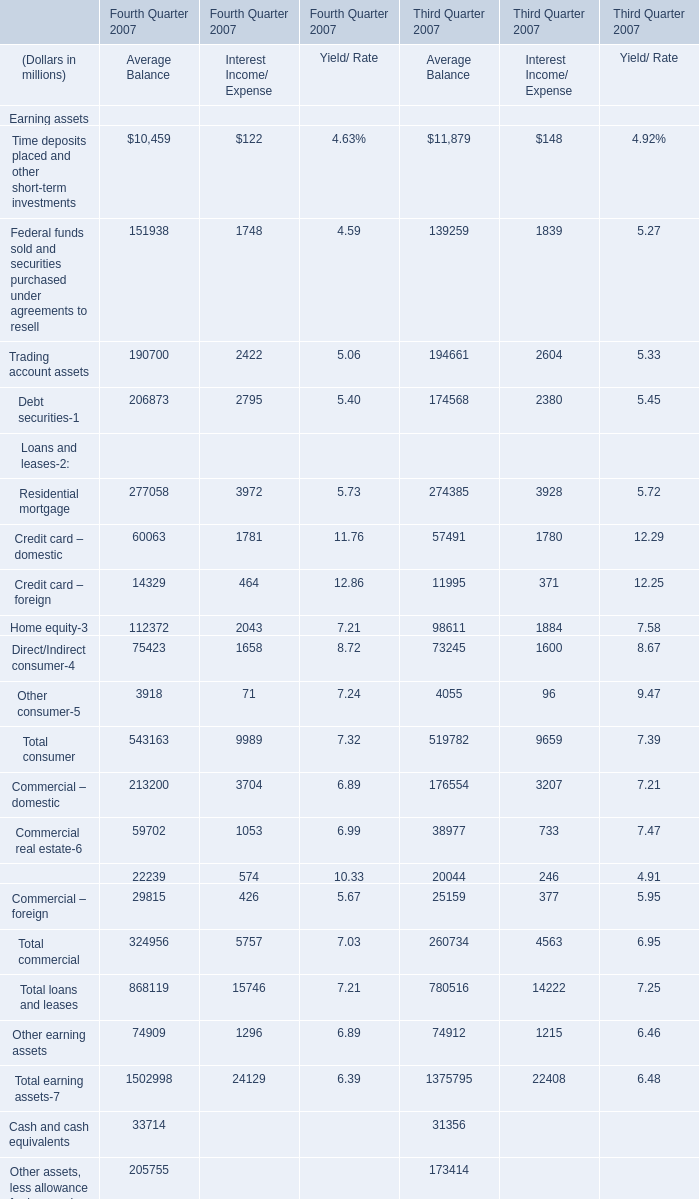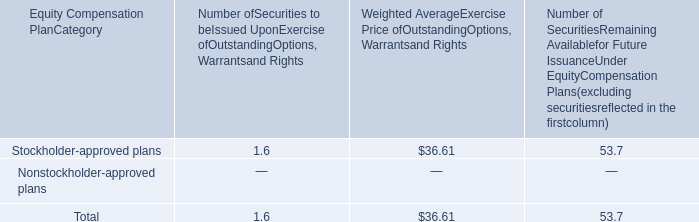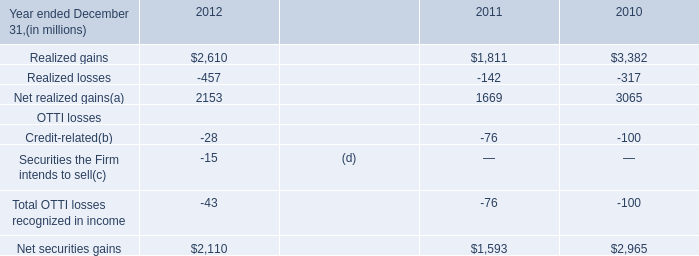what portion of the approved securities is to be issued upon exercise of outstanding options warrants rights? 
Computations: (1.6 / (1.6 + 53.7))
Answer: 0.02893. What is the average amount of Net realized gains of 2010, and Commercial – domestic of Fourth Quarter 2007 Average Balance ? 
Computations: ((3065.0 + 213200.0) / 2)
Answer: 108132.5. 